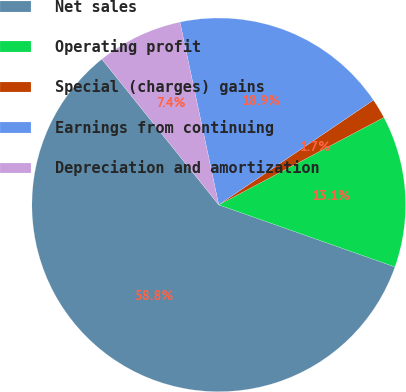<chart> <loc_0><loc_0><loc_500><loc_500><pie_chart><fcel>Net sales<fcel>Operating profit<fcel>Special (charges) gains<fcel>Earnings from continuing<fcel>Depreciation and amortization<nl><fcel>58.85%<fcel>13.14%<fcel>1.72%<fcel>18.86%<fcel>7.43%<nl></chart> 